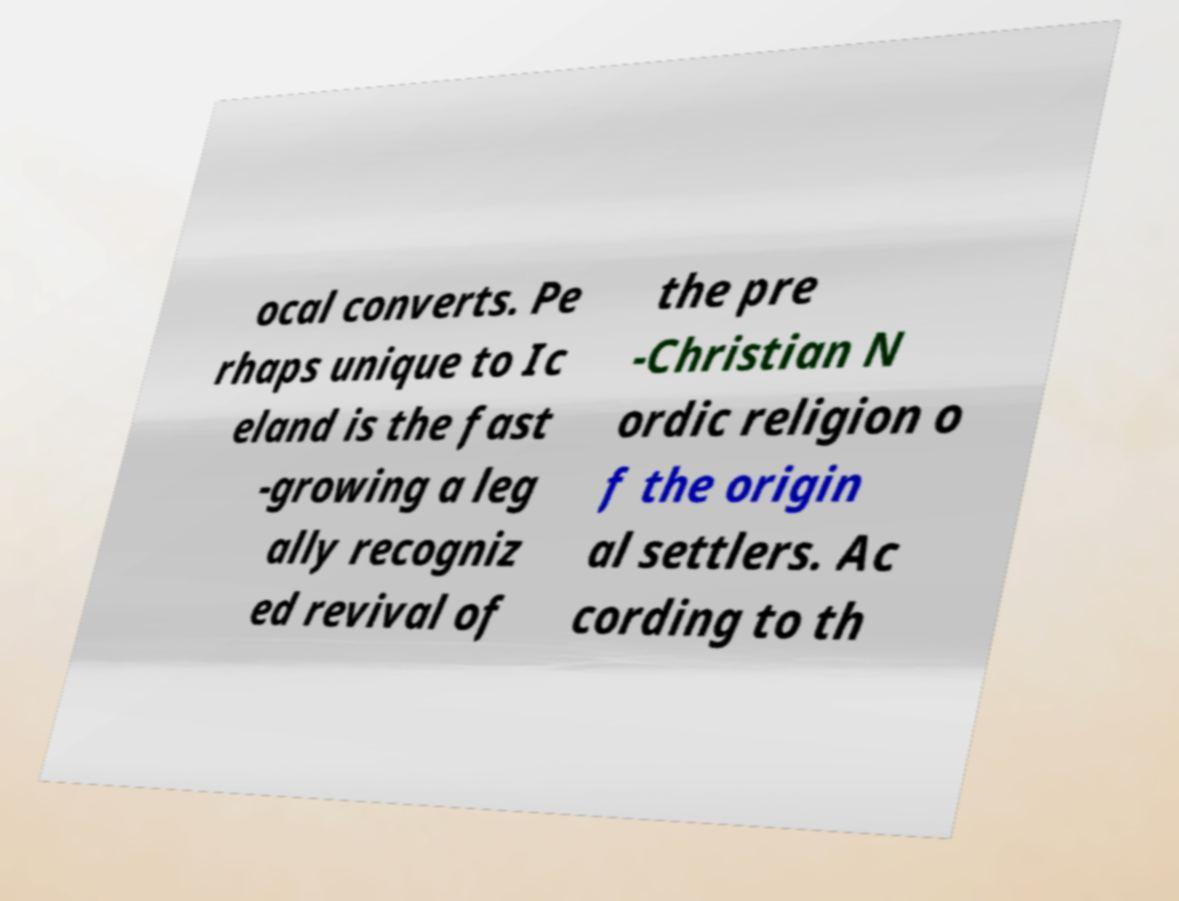Please read and relay the text visible in this image. What does it say? ocal converts. Pe rhaps unique to Ic eland is the fast -growing a leg ally recogniz ed revival of the pre -Christian N ordic religion o f the origin al settlers. Ac cording to th 